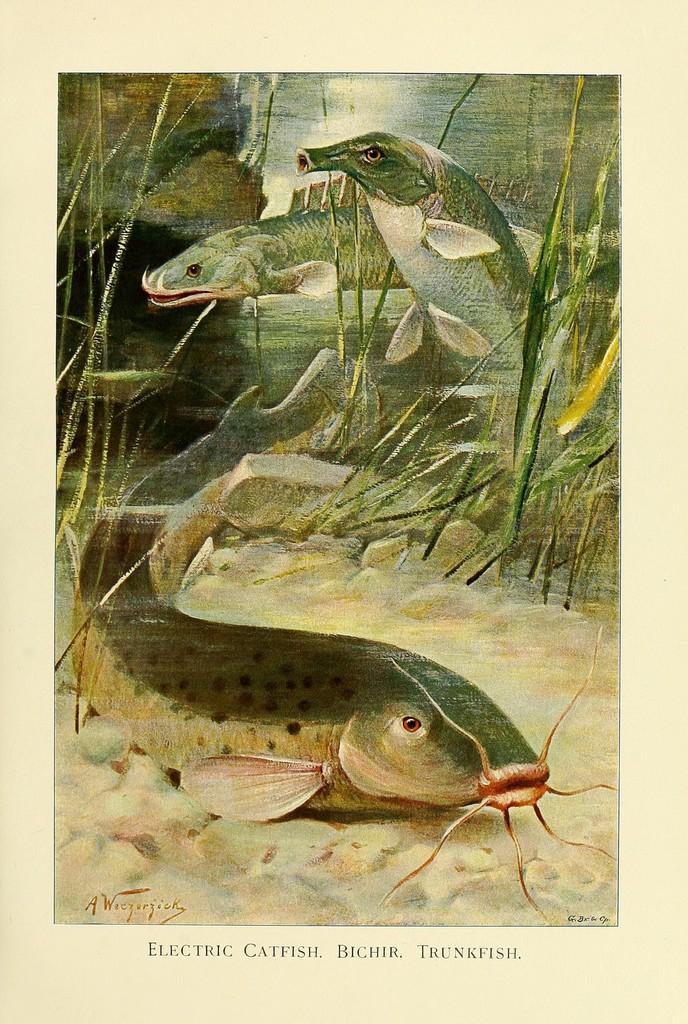How would you summarize this image in a sentence or two? In the picture we can see a painting of some fishes and grass plants and behind it we can see some rocks. 